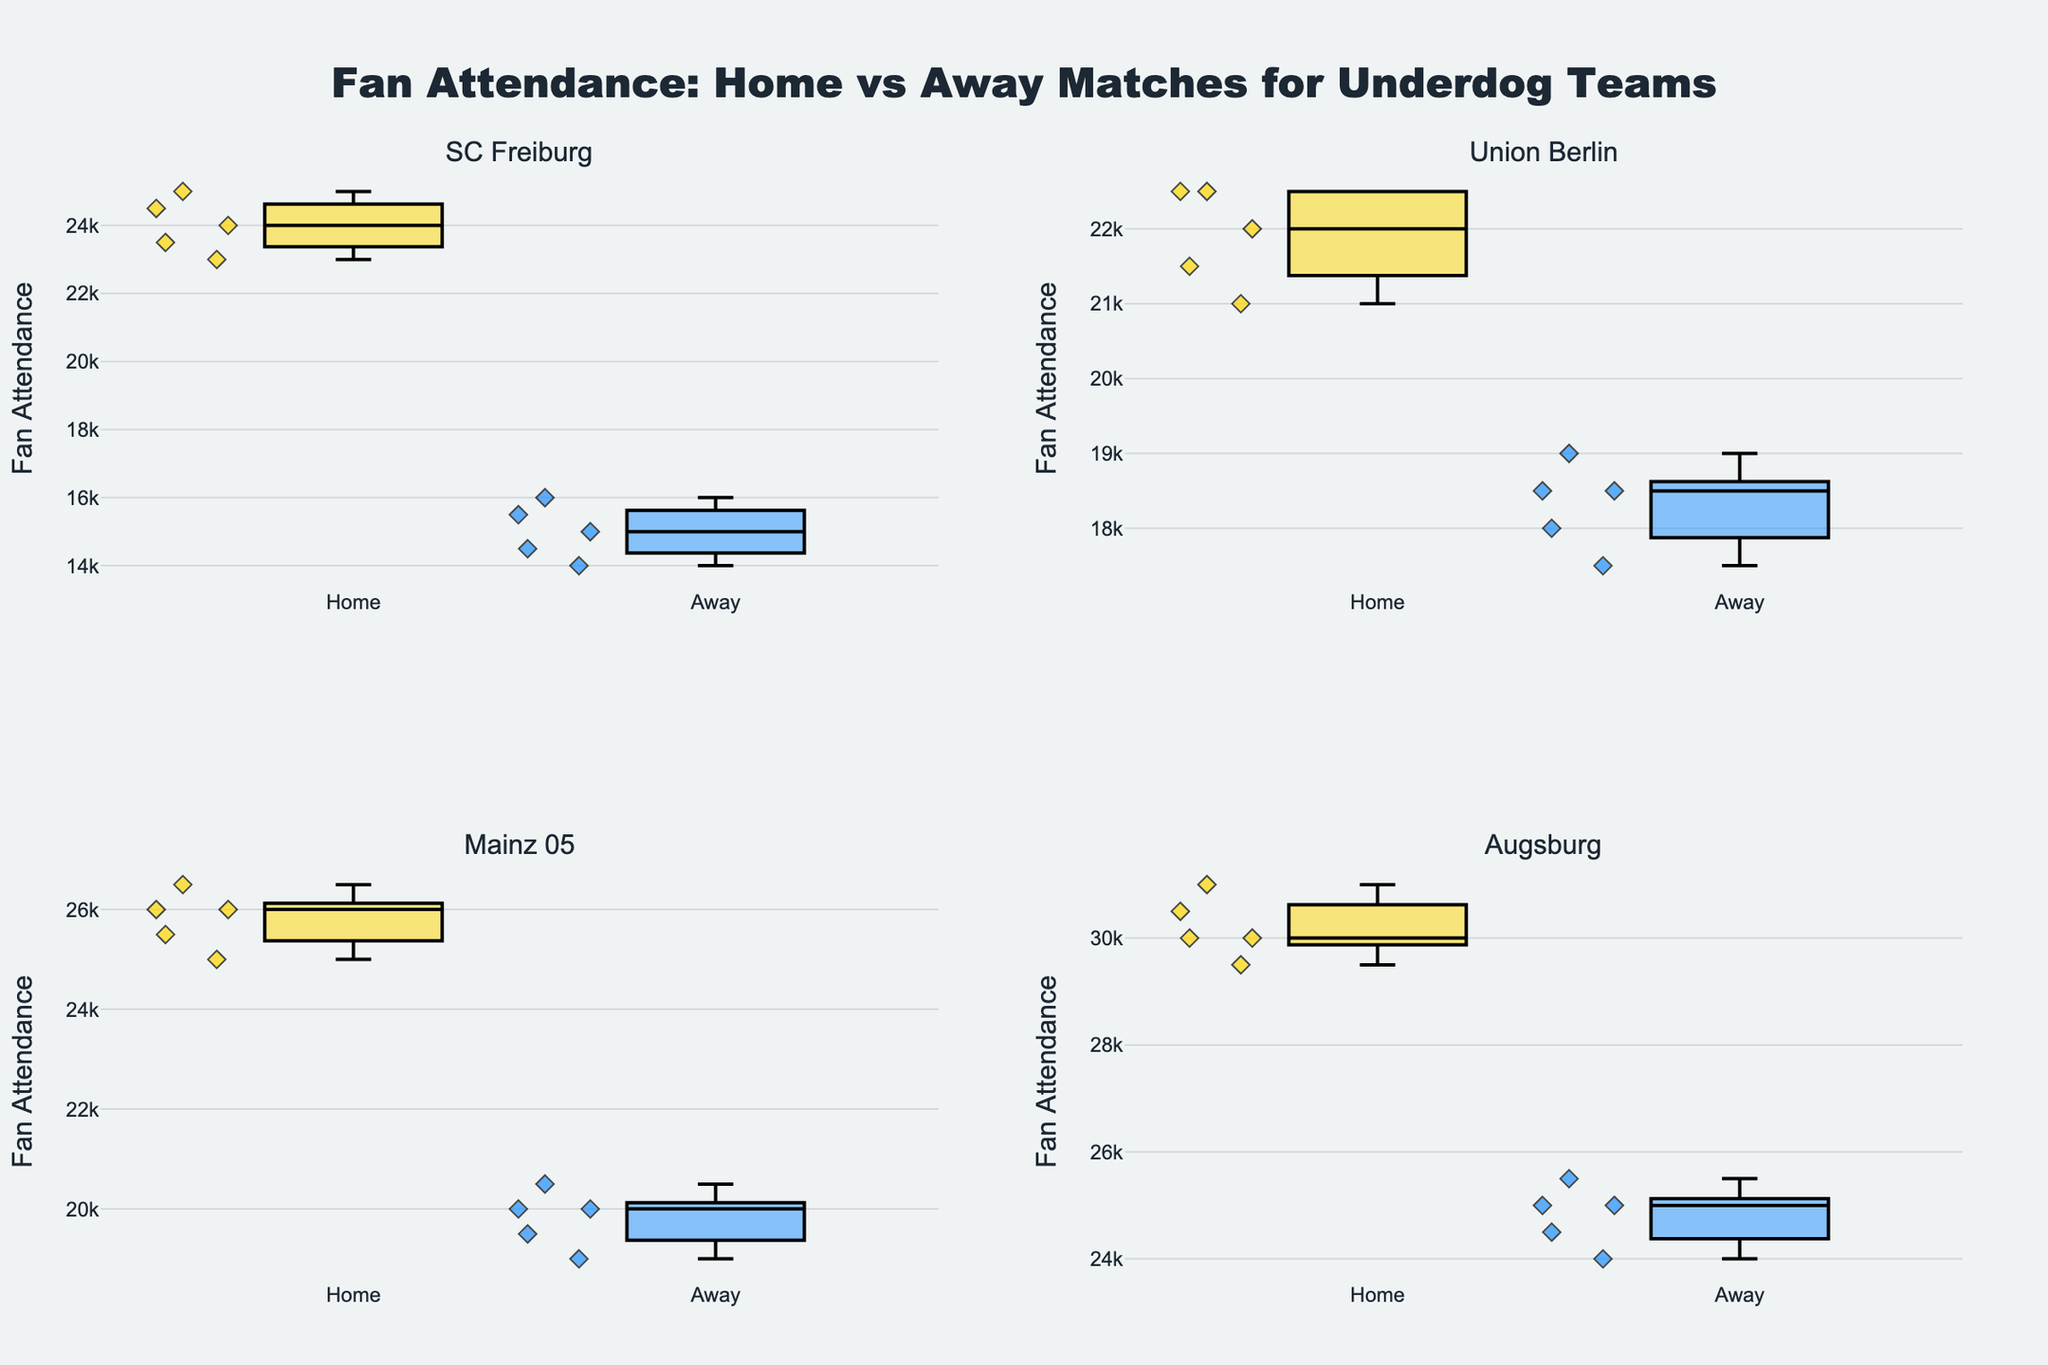What's the title of the plot? The title is located at the top center of the plot and reads: "Fan Attendance: Home vs Away Matches for Underdog Teams".
Answer: Fan Attendance: Home vs Away Matches for Underdog Teams Which teams are compared in the subplots? The subplot titles indicate the teams. The teams compared are SC Freiburg, Union Berlin, Mainz 05, and Augsburg.
Answer: SC Freiburg, Union Berlin, Mainz 05, Augsburg What are the box colors for home and away matches? The box colors are specified by the plot markers. Home matches are shown in gold, while away matches are in DodgerBlue.
Answer: Gold (Home) and DodgerBlue (Away) Which team has the highest median fan attendance for home matches? For each team's home matches, identify the central line of the box that represents the median. Augsburg has the highest median fan attendance for home matches.
Answer: Augsburg Which team has the smallest range of fan attendance for away matches? For each team's away matches, identify the vertical span of the box (from the bottom to the top whisker), indicating the range. Union Berlin has the smallest range for away matches.
Answer: Union Berlin What is the approximate median fan attendance for SC Freiburg's away matches? For SC Freiburg's away matches, locate the central line within the away box. The approximate median is 15000.
Answer: 15000 Compare the interquartile range (IQR) of home matches for SC Freiburg and Union Berlin. Which is larger? The IQR is the span of the box, between the 25th percentile (bottom of the box) and the 75th percentile (top of the box). SC Freiburg has a larger Interquartile Range compared to Union Berlin in home matches.
Answer: SC Freiburg For which teams does the median fan attendance for away matches exceed 19000? Examine the median lines of the boxes representing away matches. None of the teams have a median fan attendance for away matches exceeding 19000.
Answer: None Is the fan attendance variability higher in home or away matches for Mainz 05? Compare the spans of the boxes and whiskers for home and away matches. The variability, indicated by the range of the whiskers and the height of the box, is higher for home matches of Mainz 05.
Answer: Home matches Which match type shows more outliers for Union Berlin, home or away? Outliers are individual points plotted outside the whiskers. Union Berlin's home matches show more outliers compared to away matches.
Answer: Home matches 